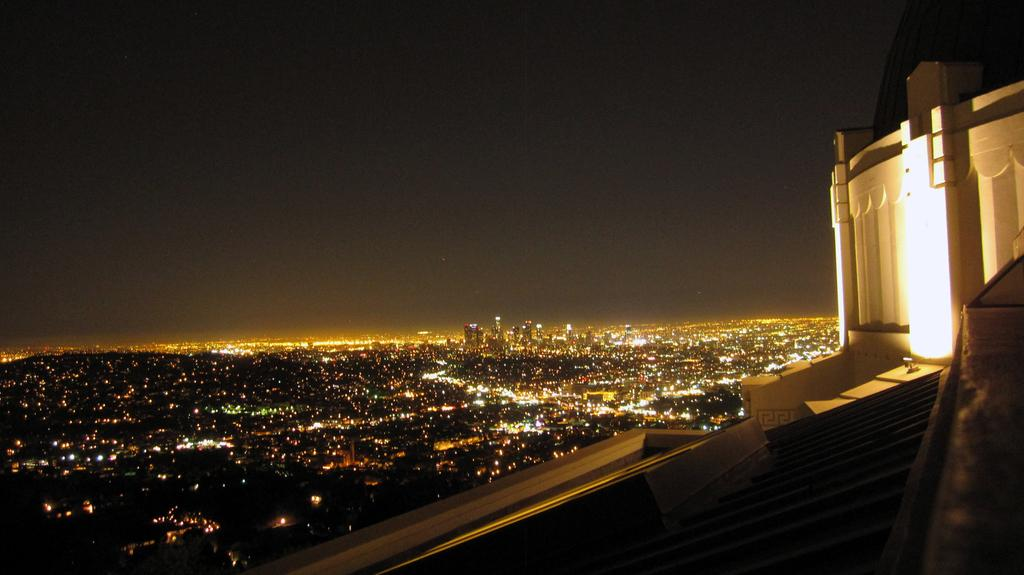What types of structures are in the foreground of the image? There are buildings and houses in the foreground of the image. What can be seen illuminated in the foreground of the image? Lights are visible in the foreground of the image. What is visible at the top of the image? The sky is visible at the top of the image. When was the image taken? The image was taken during nighttime. How many dimes can be seen on the roof of the building in the image? There are no dimes visible on the roof of the building in the image. What type of birds can be seen flying in the sky in the image? There are no birds visible in the sky in the image. 